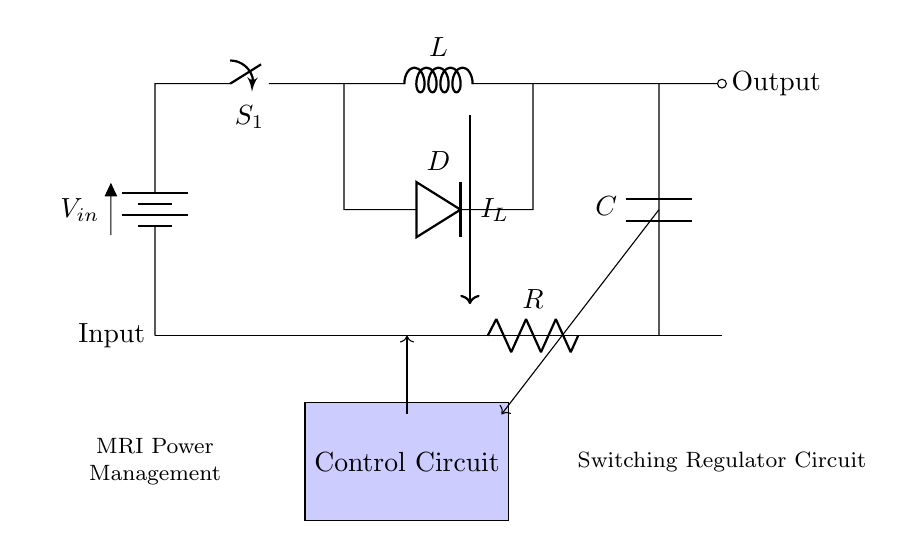What is the input component of this circuit? The input component is a battery, indicated by the symbol in the circuit diagram. It is labeled with the voltage \( V_{in} \).
Answer: battery What is the role of the inductor in this circuit? The inductor is used to store energy in the magnetic field when current flows through it, which is essential for the functioning of a switching regulator.
Answer: energy storage What component connects to the output of the circuit? The output of the circuit is connected to a capacitor, which smooths out the voltage change at the output.
Answer: capacitor What is the function of the switch labeled \( S_1 \)? The switch \( S_1 \) controls the flow of current in the circuit, allowing the inductor to charge or discharge based on its state.
Answer: current control What happens to the current when the switch \( S_1 \) is closed? When \( S_1 \) is closed, current flows through the inductor \( L \), causing it to store energy. This results in an increase in current \( I_L \) as indicated in the circuit.
Answer: stores energy What is the purpose of the diode in this circuit? The diode prevents current from flowing back into the inductor when the switch is open, ensuring that the inductor only discharges to the load.
Answer: prevents reverse flow How does the resistor \( R \) function in this circuit? The resistor \( R \) limits the current and can be used to control the output voltage level, playing an essential role in the regulation mechanism.
Answer: current limiting 